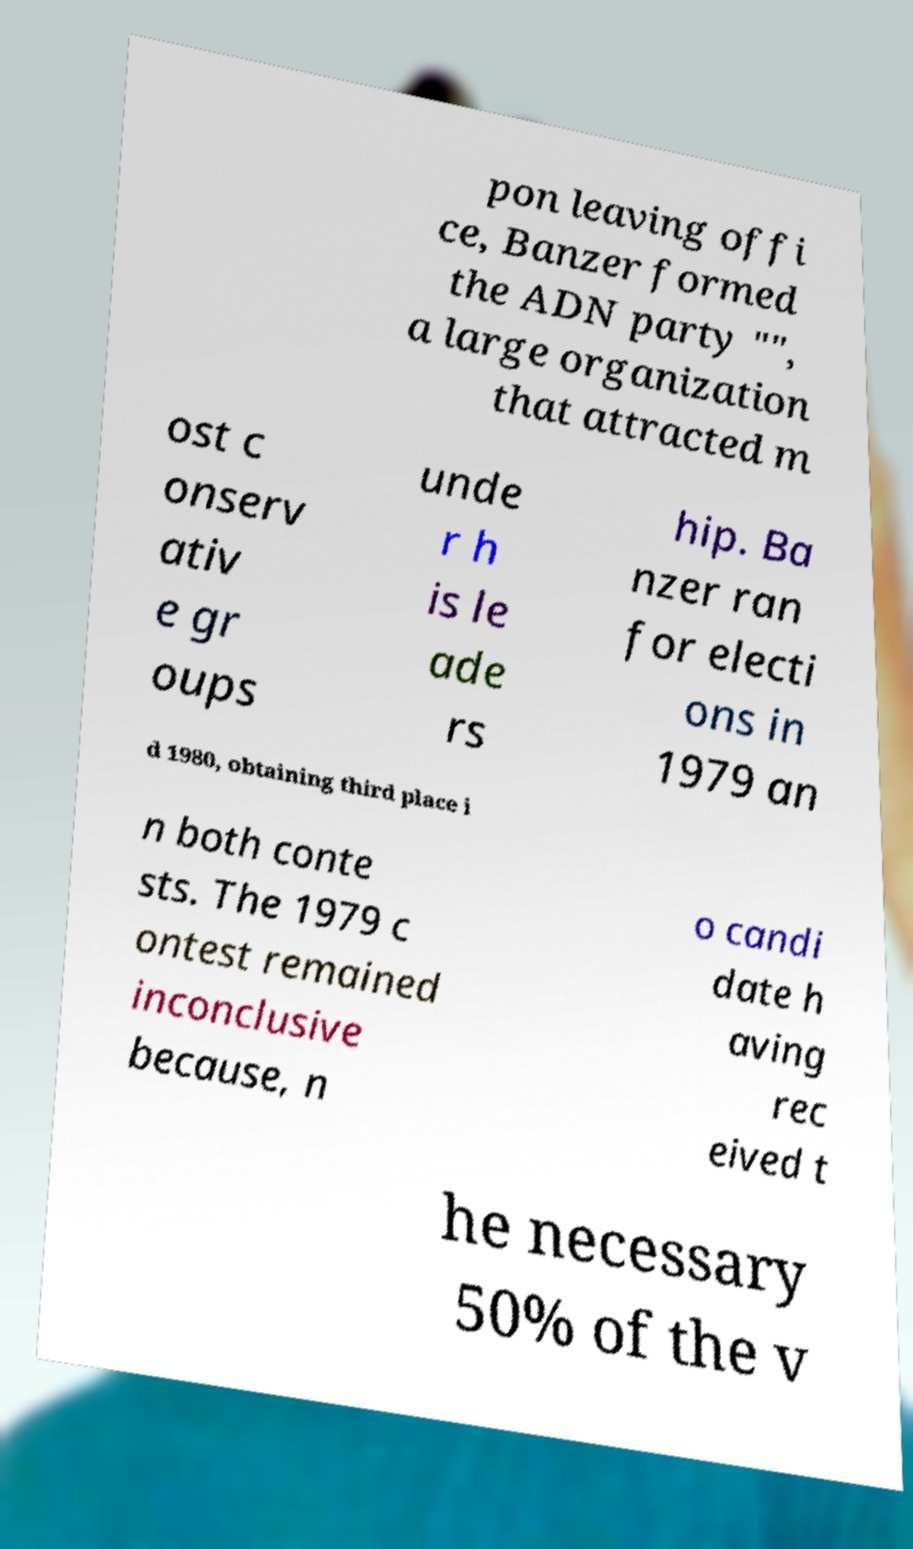Can you accurately transcribe the text from the provided image for me? pon leaving offi ce, Banzer formed the ADN party "", a large organization that attracted m ost c onserv ativ e gr oups unde r h is le ade rs hip. Ba nzer ran for electi ons in 1979 an d 1980, obtaining third place i n both conte sts. The 1979 c ontest remained inconclusive because, n o candi date h aving rec eived t he necessary 50% of the v 